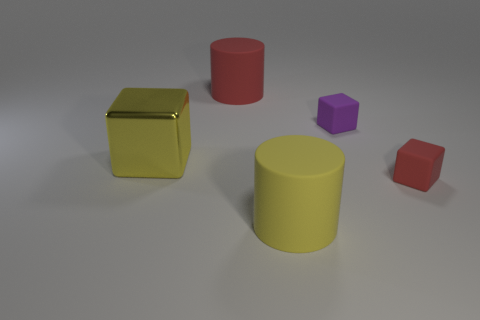What is the size of the block that is on the left side of the big red rubber object?
Your response must be concise. Large. How many large rubber objects are in front of the red matte object that is to the right of the red object left of the small red rubber block?
Your answer should be very brief. 1. What number of cylinders are in front of the small red matte object and behind the yellow metal object?
Your response must be concise. 0. What shape is the red matte object on the right side of the big red matte cylinder?
Keep it short and to the point. Cube. Is the number of tiny purple matte cubes on the left side of the small purple block less than the number of cubes to the right of the yellow metallic thing?
Provide a short and direct response. Yes. Is the material of the big red object that is left of the small red thing the same as the object to the right of the purple matte object?
Give a very brief answer. Yes. There is a large red matte object; what shape is it?
Offer a terse response. Cylinder. Is the number of big red things in front of the yellow rubber cylinder greater than the number of yellow rubber objects to the right of the big red object?
Provide a succinct answer. No. There is a big yellow object right of the big yellow metal block; is its shape the same as the object that is right of the tiny purple cube?
Your answer should be very brief. No. What number of other things are the same size as the purple rubber thing?
Provide a short and direct response. 1. 